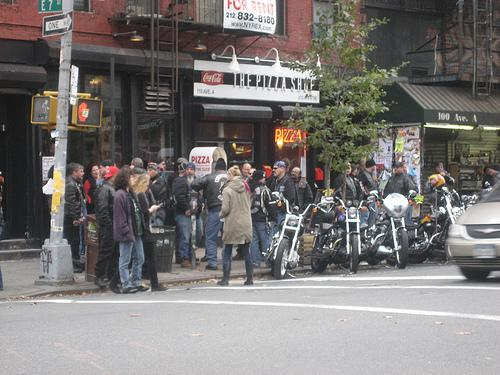What type of vehicle is parked at the curb and how many of them are there? There are several motorcycles parked at the curb. What's the color of the woman's coat, who is walking in the crosswalk? The woman's coat is light brown. What action is possibly depicted on the road, as per the captions provided? A silver car is about to enter the intersection, and a woman is walking in the crosswalk. What kind of shop is mentioned in the image description along with its specific beverage offering? A pizza shop is mentioned in the image description, and it serves Coca-Cola. List three types of signs mentioned in the image description. One way sign, Coca-Cola logo sign, and a "For Rent" sign are mentioned in the image description. Identify the type of signal at coordinate (26, 84) along with its width and height. A pedestrian crossing signal is located at coordinate (26, 84) with a width of 78 and a height of 78. Which street sign mentioned in the image description is on a pole and what does it indicate? The "One Way" sign is on a pole, indicating that this is a one-way street. In few words, describe what is happening in the street. People are gathered near parked motorcycles, and a woman crosses the street near a silver car. List the different establishments visible in the image and describe their signs. Pizza shop with cocacola logo, neon pizza sign in window, and a sign for space available for rent. Does the pizza shop serve cocacola? Yes, the pizza shop serves cocacola. Is there any object present to reduce air on a motorcycle? Yes, a motorcycle fairing What type of crossing is mentioned in the image? pedestrian crossing Write a short narrative describing the pizza shop and its surroundings. A bustling street corner houses a cozy pizza shop with a cocacola logo and a neon sign in its window. Motorcycles are parked outside, and people gather on the sidewalk nearby. A woman in a light brown coat is among the crowd. What is the main color scheme of the building above the shops? red brick Read the following caption and answer the question: 'motorcycles parked on street'. What is the main subject in the caption? motorcycles Is there a Pepsi logo on the pizza shop sign? The image shows a Coca Cola logo on the pizza shop sign, not a Pepsi logo. What is the logo visible on the sign of the pizza shop? b) Pepsi Write an alternative caption for the crowd present at the scene. Group of people gathering on the sidewalk near the pizza shop What does the address on the awning outside the shop say? 100 ave a Identify the emotion visible on the woman in the light brown coat. Not possible, no facial expressions provided Does the fire escape ladder lead to a rooftop garden? The image only shows the fire escape ladder; there is no indication of a rooftop garden. Are there bicycles parked on the street? The image shows a row of motorcycles parked on the street, not bicycles. Describe the light source under the building. A light under building can be seen shining brightly. Who can be seen walking on the pedestrian crossing? a woman in a hooded jacket Is there any traffic regulation pole present in the image? Yes, a street sign and traffic light pole are present. What does the sign caution pedestrians about? not to cross Is the neon sign advertising burgers in the window of the pizza shop? The neon sign in the window is for pizza, not burgers. Is there a man wearing a dark-colored hoodie walking in the crosswalk? The image shows a woman in a hooded jacket walking in the crosswalk, not a man wearing a dark-colored hoodie. Is the blue car about to enter the intersection? In the image, there is a silver car, not a blue car, about to enter the intersection. Provide a brief description of the activity taking place in the image. People are gathered on the street, a woman is walking on the crosswalk, and motorcycles parked on the curb. What does the caption 'a woman in a hooded jacket walks in the crosswalk' describe?  A woman wearing a hooded jacket walking in the pedestrian crossing Examine the traffic related objects in the scene and list them. one way sign, pedestrian crossing signal, crosswalk, traffic light pole, street sign What kind of banner is placed above the pizza shop? A for rent banner 